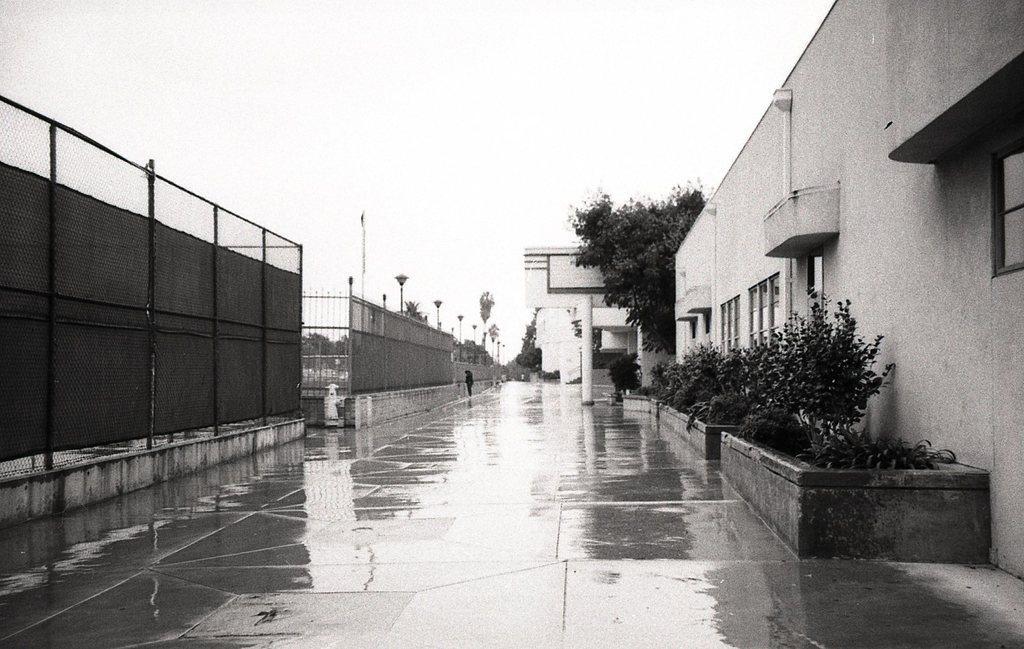Can you describe this image briefly? In this image there is a surface ground at bottom of this image and there is a fencing gate at left side of this image and there is a building at right side of this image and there are some plants at right side of his image. 